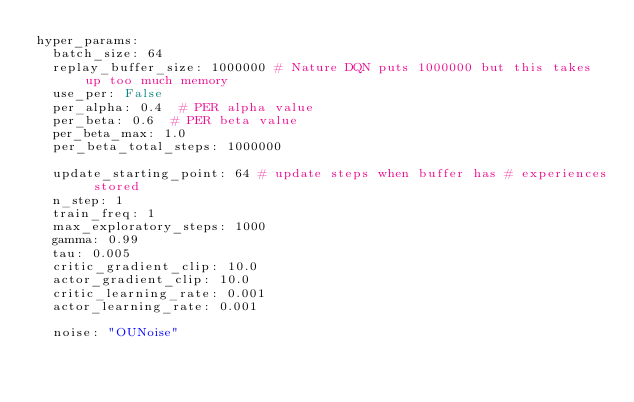<code> <loc_0><loc_0><loc_500><loc_500><_YAML_>hyper_params:
  batch_size: 64
  replay_buffer_size: 1000000 # Nature DQN puts 1000000 but this takes up too much memory
  use_per: False
  per_alpha: 0.4  # PER alpha value
  per_beta: 0.6  # PER beta value
  per_beta_max: 1.0
  per_beta_total_steps: 1000000

  update_starting_point: 64 # update steps when buffer has # experiences stored
  n_step: 1
  train_freq: 1
  max_exploratory_steps: 1000
  gamma: 0.99
  tau: 0.005
  critic_gradient_clip: 10.0
  actor_gradient_clip: 10.0
  critic_learning_rate: 0.001
  actor_learning_rate: 0.001

  noise: "OUNoise"
</code> 